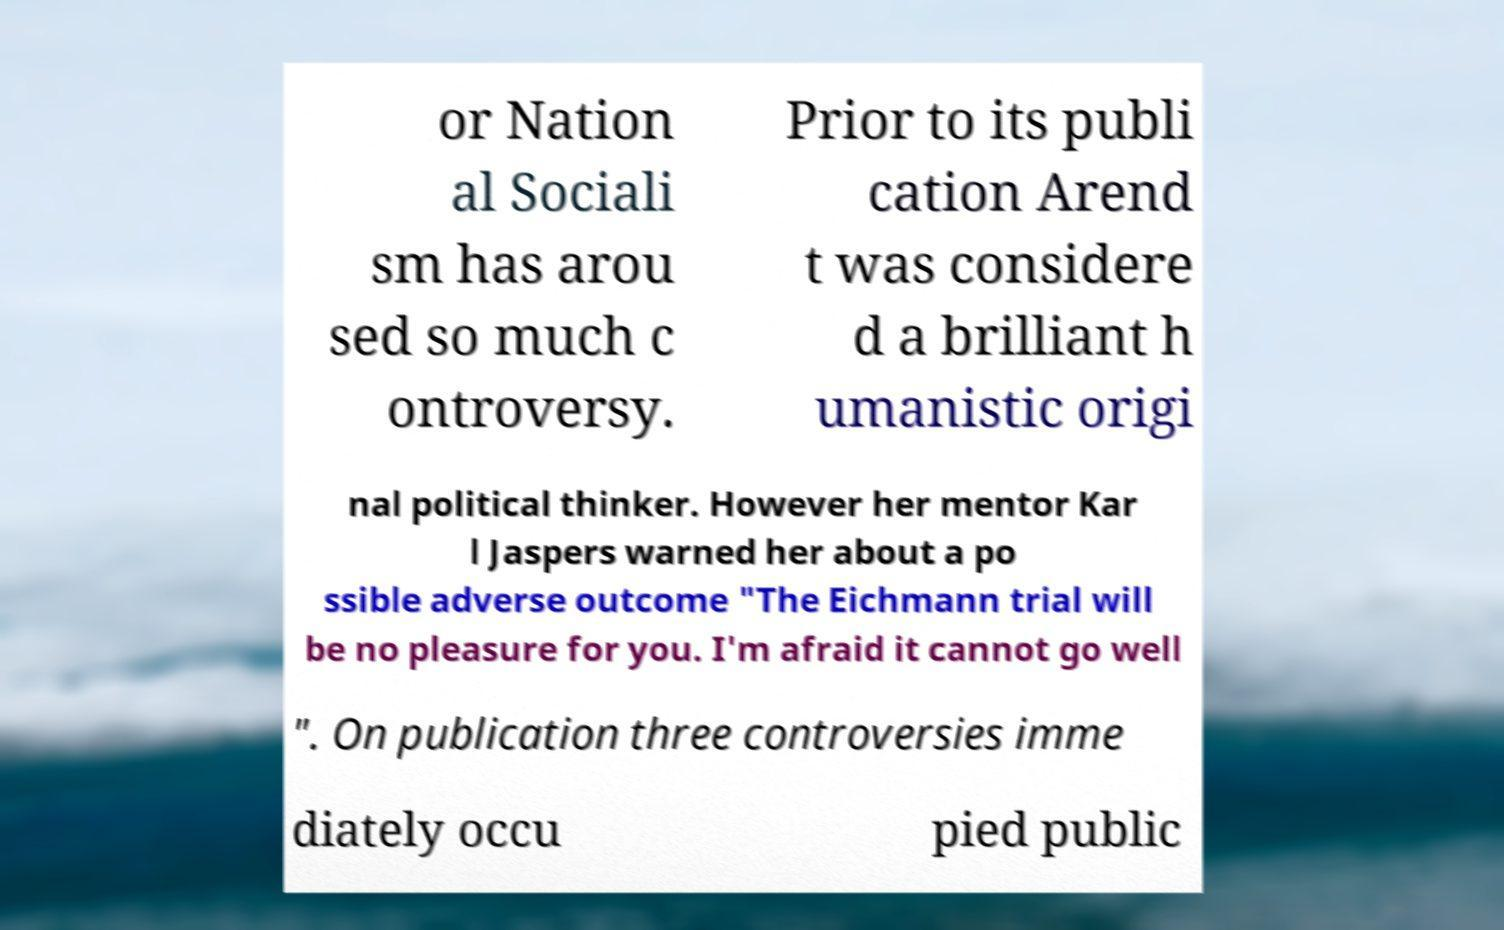For documentation purposes, I need the text within this image transcribed. Could you provide that? or Nation al Sociali sm has arou sed so much c ontroversy. Prior to its publi cation Arend t was considere d a brilliant h umanistic origi nal political thinker. However her mentor Kar l Jaspers warned her about a po ssible adverse outcome "The Eichmann trial will be no pleasure for you. I'm afraid it cannot go well ". On publication three controversies imme diately occu pied public 